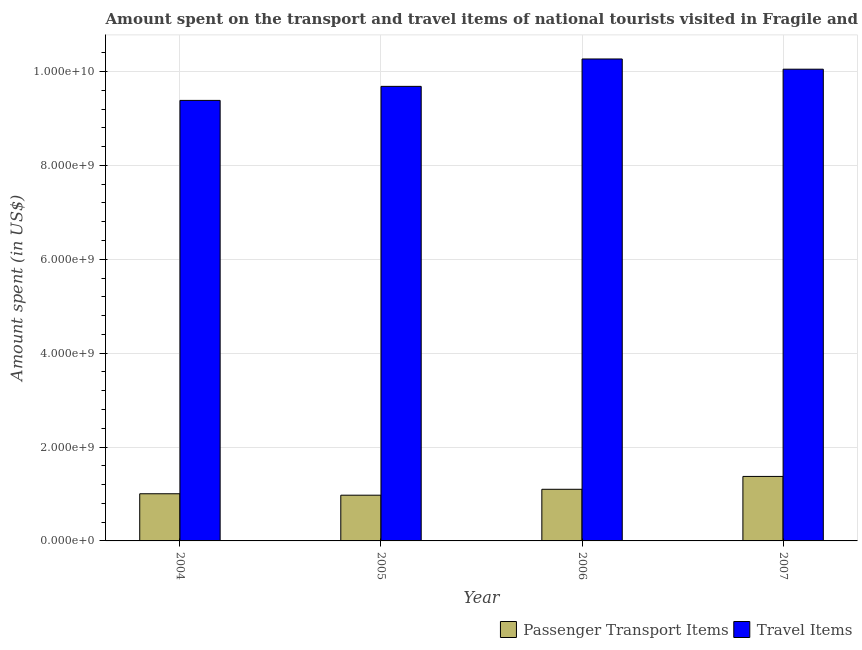Are the number of bars per tick equal to the number of legend labels?
Your answer should be very brief. Yes. Are the number of bars on each tick of the X-axis equal?
Your response must be concise. Yes. What is the amount spent in travel items in 2004?
Provide a succinct answer. 9.39e+09. Across all years, what is the maximum amount spent on passenger transport items?
Provide a short and direct response. 1.37e+09. Across all years, what is the minimum amount spent in travel items?
Offer a very short reply. 9.39e+09. In which year was the amount spent in travel items minimum?
Make the answer very short. 2004. What is the total amount spent in travel items in the graph?
Provide a succinct answer. 3.94e+1. What is the difference between the amount spent on passenger transport items in 2005 and that in 2006?
Offer a very short reply. -1.26e+08. What is the difference between the amount spent on passenger transport items in 2005 and the amount spent in travel items in 2007?
Keep it short and to the point. -4.00e+08. What is the average amount spent in travel items per year?
Make the answer very short. 9.85e+09. In how many years, is the amount spent in travel items greater than 4000000000 US$?
Your answer should be compact. 4. What is the ratio of the amount spent on passenger transport items in 2005 to that in 2006?
Provide a succinct answer. 0.89. Is the amount spent in travel items in 2005 less than that in 2007?
Offer a terse response. Yes. What is the difference between the highest and the second highest amount spent in travel items?
Your response must be concise. 2.18e+08. What is the difference between the highest and the lowest amount spent in travel items?
Give a very brief answer. 8.82e+08. Is the sum of the amount spent on passenger transport items in 2004 and 2007 greater than the maximum amount spent in travel items across all years?
Ensure brevity in your answer.  Yes. What does the 1st bar from the left in 2005 represents?
Keep it short and to the point. Passenger Transport Items. What does the 2nd bar from the right in 2005 represents?
Ensure brevity in your answer.  Passenger Transport Items. Does the graph contain grids?
Your answer should be compact. Yes. Where does the legend appear in the graph?
Provide a succinct answer. Bottom right. How many legend labels are there?
Make the answer very short. 2. How are the legend labels stacked?
Provide a short and direct response. Horizontal. What is the title of the graph?
Give a very brief answer. Amount spent on the transport and travel items of national tourists visited in Fragile and conflict affected situations. What is the label or title of the X-axis?
Ensure brevity in your answer.  Year. What is the label or title of the Y-axis?
Your response must be concise. Amount spent (in US$). What is the Amount spent (in US$) in Passenger Transport Items in 2004?
Keep it short and to the point. 1.00e+09. What is the Amount spent (in US$) of Travel Items in 2004?
Make the answer very short. 9.39e+09. What is the Amount spent (in US$) of Passenger Transport Items in 2005?
Provide a succinct answer. 9.74e+08. What is the Amount spent (in US$) in Travel Items in 2005?
Your answer should be compact. 9.68e+09. What is the Amount spent (in US$) in Passenger Transport Items in 2006?
Give a very brief answer. 1.10e+09. What is the Amount spent (in US$) in Travel Items in 2006?
Offer a terse response. 1.03e+1. What is the Amount spent (in US$) in Passenger Transport Items in 2007?
Provide a succinct answer. 1.37e+09. What is the Amount spent (in US$) in Travel Items in 2007?
Keep it short and to the point. 1.00e+1. Across all years, what is the maximum Amount spent (in US$) of Passenger Transport Items?
Ensure brevity in your answer.  1.37e+09. Across all years, what is the maximum Amount spent (in US$) in Travel Items?
Provide a succinct answer. 1.03e+1. Across all years, what is the minimum Amount spent (in US$) of Passenger Transport Items?
Your answer should be compact. 9.74e+08. Across all years, what is the minimum Amount spent (in US$) of Travel Items?
Offer a terse response. 9.39e+09. What is the total Amount spent (in US$) in Passenger Transport Items in the graph?
Make the answer very short. 4.45e+09. What is the total Amount spent (in US$) of Travel Items in the graph?
Your response must be concise. 3.94e+1. What is the difference between the Amount spent (in US$) of Passenger Transport Items in 2004 and that in 2005?
Make the answer very short. 3.06e+07. What is the difference between the Amount spent (in US$) of Travel Items in 2004 and that in 2005?
Offer a terse response. -2.99e+08. What is the difference between the Amount spent (in US$) in Passenger Transport Items in 2004 and that in 2006?
Offer a terse response. -9.54e+07. What is the difference between the Amount spent (in US$) of Travel Items in 2004 and that in 2006?
Offer a very short reply. -8.82e+08. What is the difference between the Amount spent (in US$) of Passenger Transport Items in 2004 and that in 2007?
Make the answer very short. -3.69e+08. What is the difference between the Amount spent (in US$) in Travel Items in 2004 and that in 2007?
Offer a terse response. -6.65e+08. What is the difference between the Amount spent (in US$) of Passenger Transport Items in 2005 and that in 2006?
Offer a terse response. -1.26e+08. What is the difference between the Amount spent (in US$) of Travel Items in 2005 and that in 2006?
Your answer should be compact. -5.84e+08. What is the difference between the Amount spent (in US$) in Passenger Transport Items in 2005 and that in 2007?
Give a very brief answer. -4.00e+08. What is the difference between the Amount spent (in US$) of Travel Items in 2005 and that in 2007?
Your answer should be compact. -3.66e+08. What is the difference between the Amount spent (in US$) of Passenger Transport Items in 2006 and that in 2007?
Provide a short and direct response. -2.74e+08. What is the difference between the Amount spent (in US$) in Travel Items in 2006 and that in 2007?
Provide a short and direct response. 2.18e+08. What is the difference between the Amount spent (in US$) of Passenger Transport Items in 2004 and the Amount spent (in US$) of Travel Items in 2005?
Offer a terse response. -8.68e+09. What is the difference between the Amount spent (in US$) of Passenger Transport Items in 2004 and the Amount spent (in US$) of Travel Items in 2006?
Keep it short and to the point. -9.26e+09. What is the difference between the Amount spent (in US$) of Passenger Transport Items in 2004 and the Amount spent (in US$) of Travel Items in 2007?
Provide a succinct answer. -9.05e+09. What is the difference between the Amount spent (in US$) in Passenger Transport Items in 2005 and the Amount spent (in US$) in Travel Items in 2006?
Give a very brief answer. -9.29e+09. What is the difference between the Amount spent (in US$) in Passenger Transport Items in 2005 and the Amount spent (in US$) in Travel Items in 2007?
Offer a very short reply. -9.08e+09. What is the difference between the Amount spent (in US$) of Passenger Transport Items in 2006 and the Amount spent (in US$) of Travel Items in 2007?
Offer a terse response. -8.95e+09. What is the average Amount spent (in US$) of Passenger Transport Items per year?
Provide a succinct answer. 1.11e+09. What is the average Amount spent (in US$) of Travel Items per year?
Your answer should be very brief. 9.85e+09. In the year 2004, what is the difference between the Amount spent (in US$) in Passenger Transport Items and Amount spent (in US$) in Travel Items?
Give a very brief answer. -8.38e+09. In the year 2005, what is the difference between the Amount spent (in US$) in Passenger Transport Items and Amount spent (in US$) in Travel Items?
Offer a very short reply. -8.71e+09. In the year 2006, what is the difference between the Amount spent (in US$) of Passenger Transport Items and Amount spent (in US$) of Travel Items?
Your answer should be compact. -9.17e+09. In the year 2007, what is the difference between the Amount spent (in US$) in Passenger Transport Items and Amount spent (in US$) in Travel Items?
Give a very brief answer. -8.68e+09. What is the ratio of the Amount spent (in US$) in Passenger Transport Items in 2004 to that in 2005?
Your answer should be very brief. 1.03. What is the ratio of the Amount spent (in US$) in Travel Items in 2004 to that in 2005?
Your response must be concise. 0.97. What is the ratio of the Amount spent (in US$) of Passenger Transport Items in 2004 to that in 2006?
Ensure brevity in your answer.  0.91. What is the ratio of the Amount spent (in US$) of Travel Items in 2004 to that in 2006?
Ensure brevity in your answer.  0.91. What is the ratio of the Amount spent (in US$) in Passenger Transport Items in 2004 to that in 2007?
Your answer should be compact. 0.73. What is the ratio of the Amount spent (in US$) in Travel Items in 2004 to that in 2007?
Your answer should be very brief. 0.93. What is the ratio of the Amount spent (in US$) in Passenger Transport Items in 2005 to that in 2006?
Make the answer very short. 0.89. What is the ratio of the Amount spent (in US$) of Travel Items in 2005 to that in 2006?
Your answer should be compact. 0.94. What is the ratio of the Amount spent (in US$) in Passenger Transport Items in 2005 to that in 2007?
Your response must be concise. 0.71. What is the ratio of the Amount spent (in US$) in Travel Items in 2005 to that in 2007?
Ensure brevity in your answer.  0.96. What is the ratio of the Amount spent (in US$) in Passenger Transport Items in 2006 to that in 2007?
Your answer should be compact. 0.8. What is the ratio of the Amount spent (in US$) in Travel Items in 2006 to that in 2007?
Your response must be concise. 1.02. What is the difference between the highest and the second highest Amount spent (in US$) of Passenger Transport Items?
Ensure brevity in your answer.  2.74e+08. What is the difference between the highest and the second highest Amount spent (in US$) of Travel Items?
Offer a very short reply. 2.18e+08. What is the difference between the highest and the lowest Amount spent (in US$) of Passenger Transport Items?
Give a very brief answer. 4.00e+08. What is the difference between the highest and the lowest Amount spent (in US$) of Travel Items?
Keep it short and to the point. 8.82e+08. 